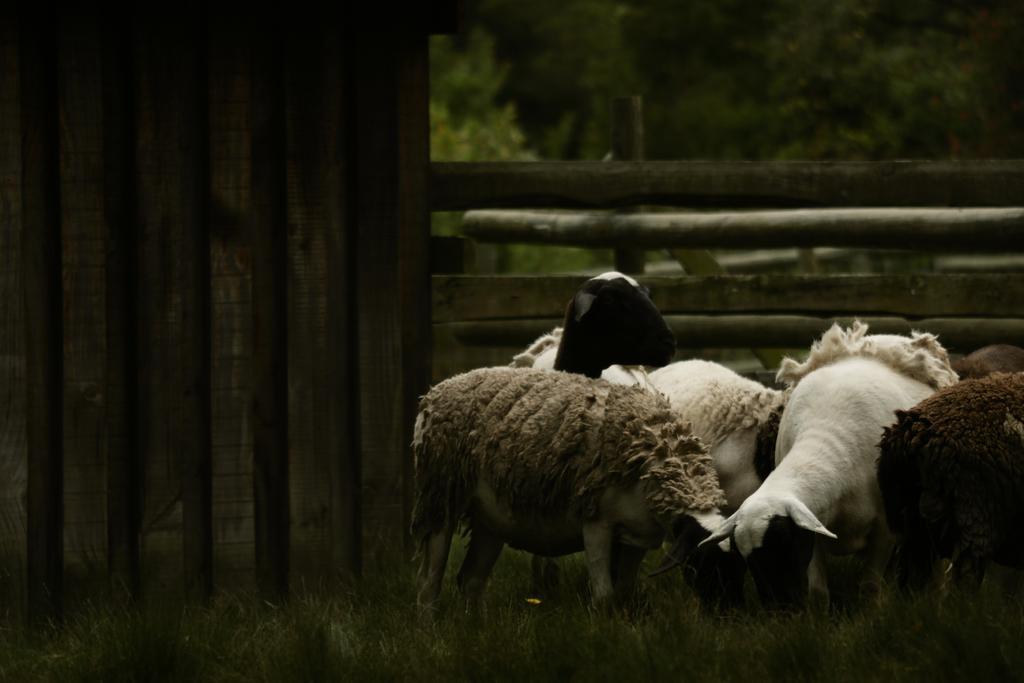What animals can be seen on the ground in the image? There is a group of goats on the ground in the image. What type of vegetation is present in the image? There are trees and grass in the image. What feature can be seen surrounding the area in the image? There is fencing in the image. What type of pear is hanging from the tree in the image? There is no pear present in the image; it features a group of goats, trees, grass, and fencing. What metal object can be seen interacting with the goats in the image? There is no metal object present in the image that interacts with the goats. 